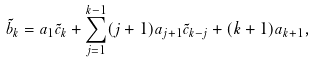<formula> <loc_0><loc_0><loc_500><loc_500>\tilde { b } _ { k } = { a } _ { 1 } \tilde { c } _ { k } + \sum _ { j = 1 } ^ { k - 1 } ( j + 1 ) { a } _ { j + 1 } \tilde { c } _ { k - j } + ( k + 1 ) { a } _ { k + 1 } ,</formula> 